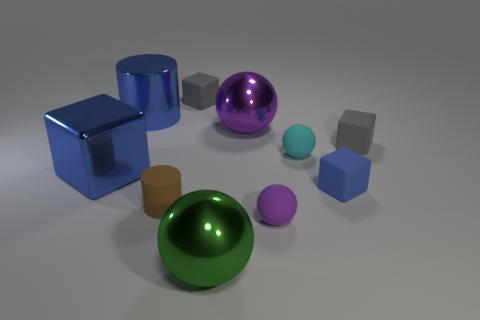Is the blue metallic block the same size as the brown matte thing?
Keep it short and to the point. No. Are there any green things?
Keep it short and to the point. Yes. What is the size of the rubber thing that is the same color as the large metal cylinder?
Your answer should be very brief. Small. What size is the gray matte cube that is in front of the small gray block behind the cylinder that is behind the big purple object?
Give a very brief answer. Small. How many blue blocks are the same material as the small brown thing?
Provide a short and direct response. 1. What number of blue cylinders are the same size as the purple shiny sphere?
Your response must be concise. 1. There is a small gray cube behind the tiny gray matte object on the right side of the gray thing on the left side of the blue rubber block; what is its material?
Your answer should be very brief. Rubber. How many objects are either blue cylinders or small blocks?
Your response must be concise. 4. Is there any other thing that is made of the same material as the tiny brown cylinder?
Keep it short and to the point. Yes. What is the shape of the brown object?
Your answer should be compact. Cylinder. 